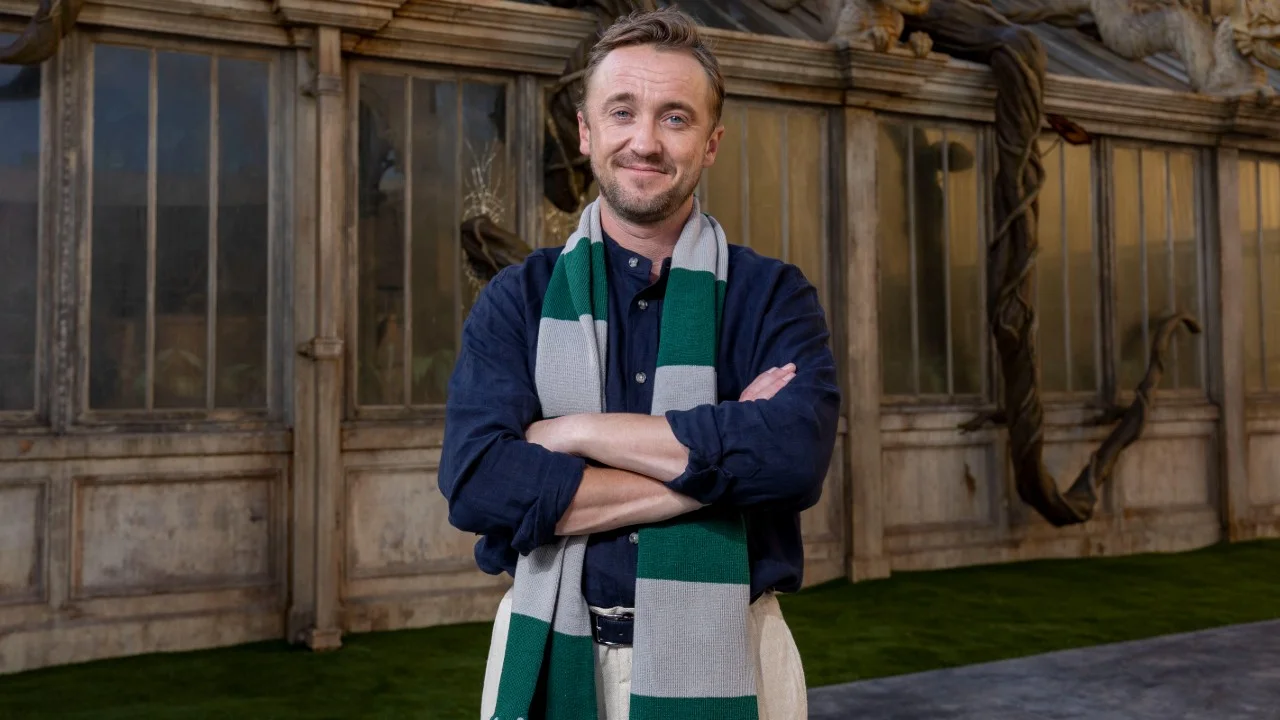What can you tell about the architectural style seen through the window behind the man? The architectural style visible through the window is distinctly gothic, characterized by its arched windows, use of stone, and ornate detailing. This style often conveys a sense of grandeur and historical depth, which might suggest that the building is of significant historical or cultural importance, possibly a museum, historical institution, or a similarly themed setting. 